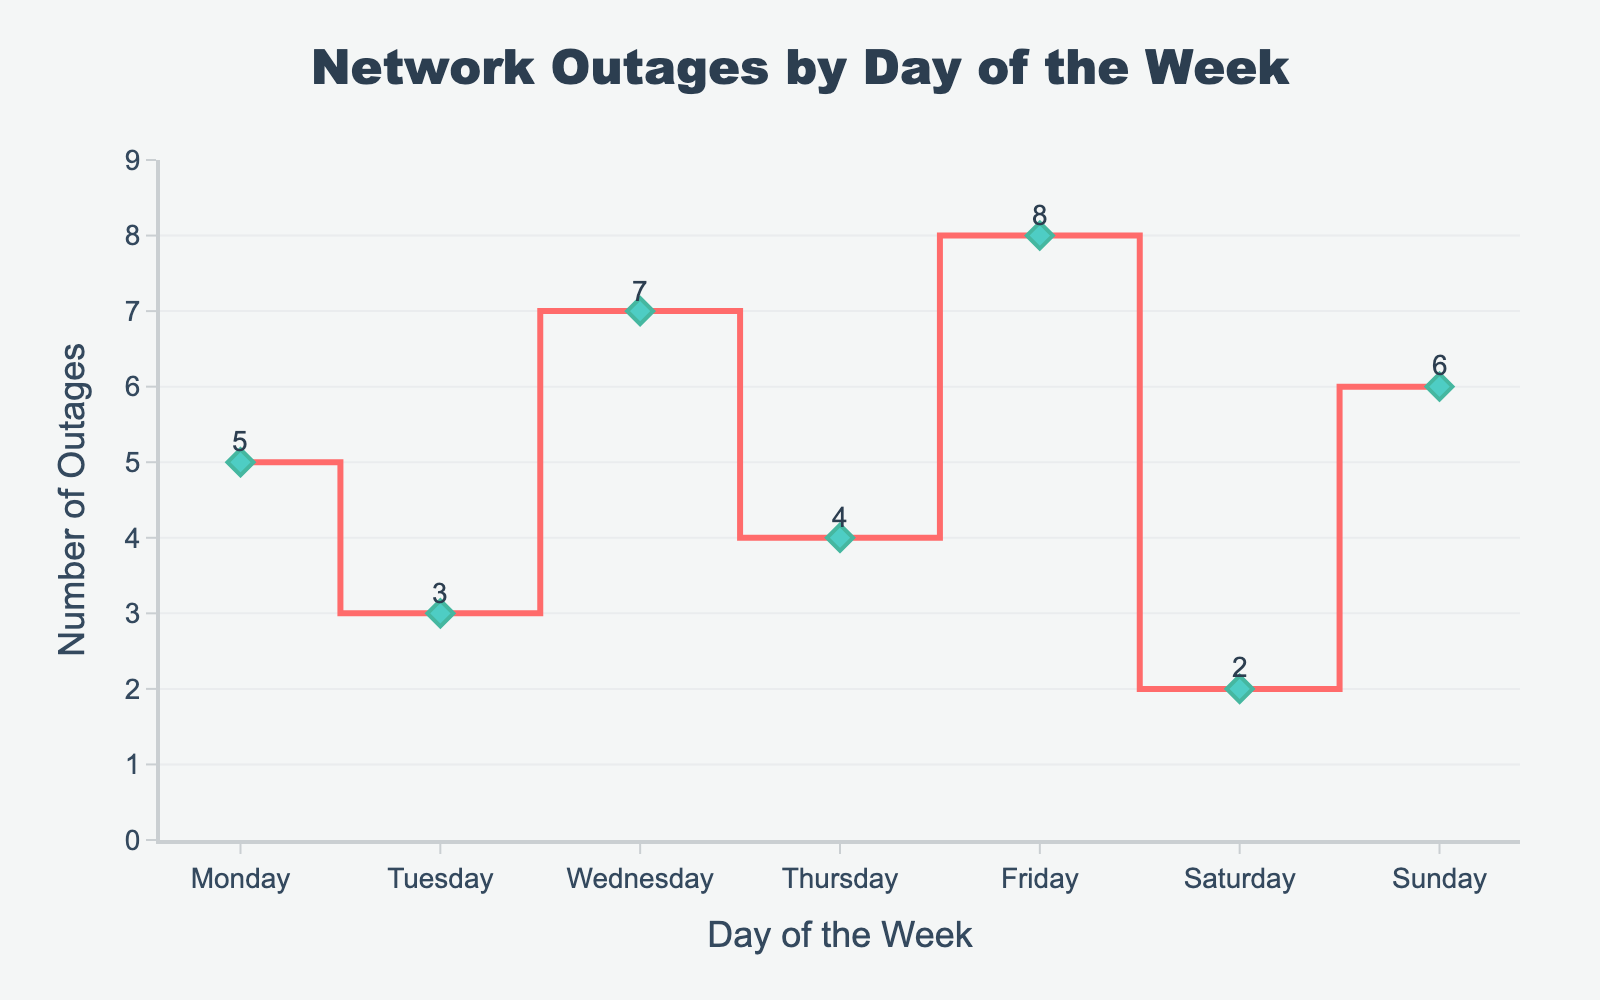What is the title of the plot? The title of the plot is usually found at the top of the figure. In this case, it reads 'Network Outages by Day of the Week'.
Answer: 'Network Outages by Day of the Week' Which day has the highest number of network outages? The plot shows the number of outages per day. The point representing Friday has the highest value.
Answer: Friday How many network outages occurred on Sunday? You can find the number by looking at the value marked on Sunday. It shows that there are 6 outages.
Answer: 6 What is the total number of network outages for the entire week? Add the number of outages for each day: 5 (Monday) + 3 (Tuesday) + 7 (Wednesday) + 4 (Thursday) + 8 (Friday) + 2 (Saturday) + 6 (Sunday) = 35.
Answer: 35 Which day has the lowest number of network outages? The plot shows the number of outages per day. The point representing Saturday has the lowest value, which is 2.
Answer: Saturday How many more outages occurred on Friday compared to Tuesday? Subtract the number of outages on Tuesday from those on Friday: 8 (Friday) - 3 (Tuesday) = 5.
Answer: 5 What is the average number of network outages per day for the week? Sum the total number of outages and divide by the number of days: (5 + 3 + 7 + 4 + 8 + 2 + 6)/7 = 35/7 = 5.
Answer: 5 Is there a day with an equal number of network outages as Monday? Yes, checking the plot, Sunday also has 6 network outages like Monday.
Answer: Yes On which days did the network outages increase compared to the previous day? Check each pair of consecutive days: 
- Monday to Tuesday: decrease (5 to 3)
- Tuesday to Wednesday: increase (3 to 7)
- Wednesday to Thursday: decrease (7 to 4)
- Thursday to Friday: increase (4 to 8)
- Friday to Saturday: decrease (8 to 2)
- Saturday to Sunday: increase (2 to 6) 
So, Tuesday to Wednesday, Thursday to Friday, and Saturday to Sunday.
Answer: Wednesday, Friday, Sunday What is the range of the number of network outages throughout the week? Find the difference between the maximum and minimum values: 8 (Friday) - 2 (Saturday) = 6.
Answer: 6 